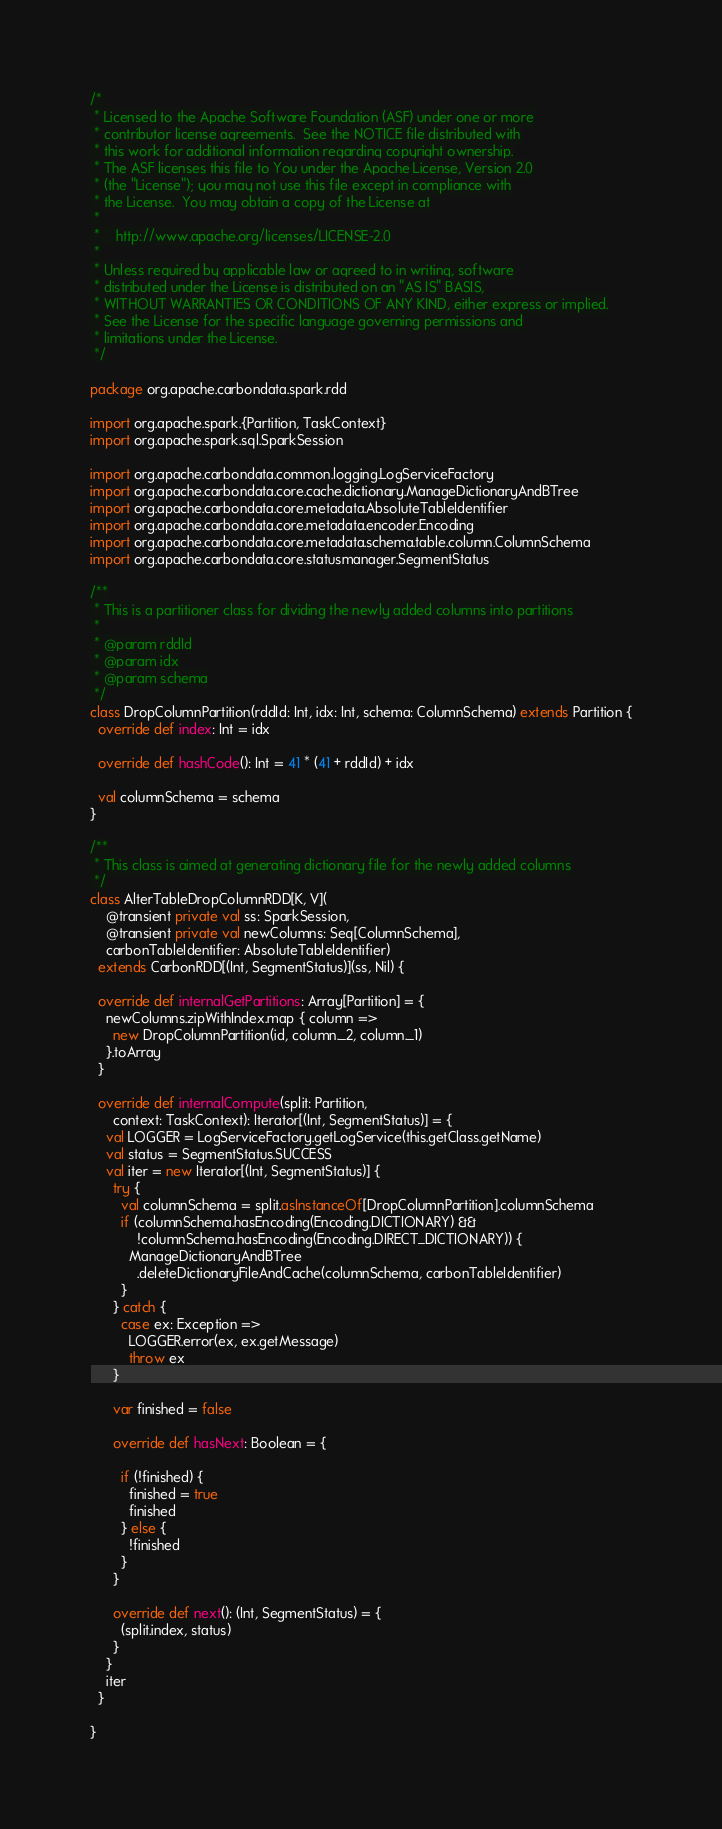Convert code to text. <code><loc_0><loc_0><loc_500><loc_500><_Scala_>/*
 * Licensed to the Apache Software Foundation (ASF) under one or more
 * contributor license agreements.  See the NOTICE file distributed with
 * this work for additional information regarding copyright ownership.
 * The ASF licenses this file to You under the Apache License, Version 2.0
 * (the "License"); you may not use this file except in compliance with
 * the License.  You may obtain a copy of the License at
 *
 *    http://www.apache.org/licenses/LICENSE-2.0
 *
 * Unless required by applicable law or agreed to in writing, software
 * distributed under the License is distributed on an "AS IS" BASIS,
 * WITHOUT WARRANTIES OR CONDITIONS OF ANY KIND, either express or implied.
 * See the License for the specific language governing permissions and
 * limitations under the License.
 */

package org.apache.carbondata.spark.rdd

import org.apache.spark.{Partition, TaskContext}
import org.apache.spark.sql.SparkSession

import org.apache.carbondata.common.logging.LogServiceFactory
import org.apache.carbondata.core.cache.dictionary.ManageDictionaryAndBTree
import org.apache.carbondata.core.metadata.AbsoluteTableIdentifier
import org.apache.carbondata.core.metadata.encoder.Encoding
import org.apache.carbondata.core.metadata.schema.table.column.ColumnSchema
import org.apache.carbondata.core.statusmanager.SegmentStatus

/**
 * This is a partitioner class for dividing the newly added columns into partitions
 *
 * @param rddId
 * @param idx
 * @param schema
 */
class DropColumnPartition(rddId: Int, idx: Int, schema: ColumnSchema) extends Partition {
  override def index: Int = idx

  override def hashCode(): Int = 41 * (41 + rddId) + idx

  val columnSchema = schema
}

/**
 * This class is aimed at generating dictionary file for the newly added columns
 */
class AlterTableDropColumnRDD[K, V](
    @transient private val ss: SparkSession,
    @transient private val newColumns: Seq[ColumnSchema],
    carbonTableIdentifier: AbsoluteTableIdentifier)
  extends CarbonRDD[(Int, SegmentStatus)](ss, Nil) {

  override def internalGetPartitions: Array[Partition] = {
    newColumns.zipWithIndex.map { column =>
      new DropColumnPartition(id, column._2, column._1)
    }.toArray
  }

  override def internalCompute(split: Partition,
      context: TaskContext): Iterator[(Int, SegmentStatus)] = {
    val LOGGER = LogServiceFactory.getLogService(this.getClass.getName)
    val status = SegmentStatus.SUCCESS
    val iter = new Iterator[(Int, SegmentStatus)] {
      try {
        val columnSchema = split.asInstanceOf[DropColumnPartition].columnSchema
        if (columnSchema.hasEncoding(Encoding.DICTIONARY) &&
            !columnSchema.hasEncoding(Encoding.DIRECT_DICTIONARY)) {
          ManageDictionaryAndBTree
            .deleteDictionaryFileAndCache(columnSchema, carbonTableIdentifier)
        }
      } catch {
        case ex: Exception =>
          LOGGER.error(ex, ex.getMessage)
          throw ex
      }

      var finished = false

      override def hasNext: Boolean = {

        if (!finished) {
          finished = true
          finished
        } else {
          !finished
        }
      }

      override def next(): (Int, SegmentStatus) = {
        (split.index, status)
      }
    }
    iter
  }

}
</code> 